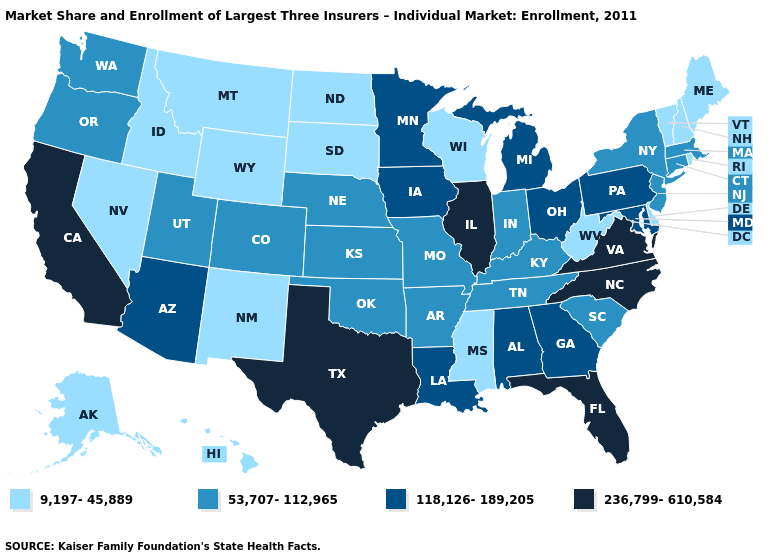Does West Virginia have a lower value than Maine?
Give a very brief answer. No. Name the states that have a value in the range 236,799-610,584?
Keep it brief. California, Florida, Illinois, North Carolina, Texas, Virginia. What is the value of California?
Quick response, please. 236,799-610,584. Among the states that border New Hampshire , does Maine have the lowest value?
Be succinct. Yes. Does the map have missing data?
Be succinct. No. How many symbols are there in the legend?
Short answer required. 4. Among the states that border Kentucky , which have the highest value?
Write a very short answer. Illinois, Virginia. Does Connecticut have the same value as Vermont?
Short answer required. No. What is the highest value in the West ?
Answer briefly. 236,799-610,584. Name the states that have a value in the range 9,197-45,889?
Answer briefly. Alaska, Delaware, Hawaii, Idaho, Maine, Mississippi, Montana, Nevada, New Hampshire, New Mexico, North Dakota, Rhode Island, South Dakota, Vermont, West Virginia, Wisconsin, Wyoming. Name the states that have a value in the range 118,126-189,205?
Give a very brief answer. Alabama, Arizona, Georgia, Iowa, Louisiana, Maryland, Michigan, Minnesota, Ohio, Pennsylvania. Among the states that border Colorado , which have the lowest value?
Keep it brief. New Mexico, Wyoming. Which states have the lowest value in the Northeast?
Answer briefly. Maine, New Hampshire, Rhode Island, Vermont. What is the value of Rhode Island?
Write a very short answer. 9,197-45,889. What is the value of Alaska?
Give a very brief answer. 9,197-45,889. 